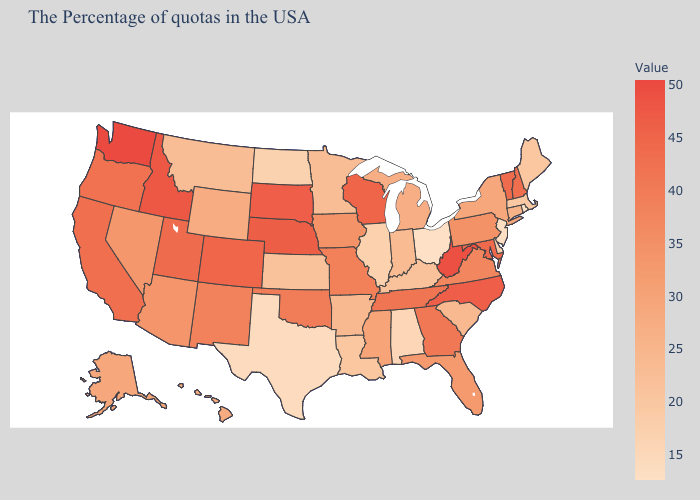Does Hawaii have a higher value than South Dakota?
Write a very short answer. No. Which states have the lowest value in the USA?
Give a very brief answer. Ohio. Does Montana have a lower value than Oregon?
Answer briefly. Yes. Which states have the lowest value in the Northeast?
Write a very short answer. Rhode Island. 